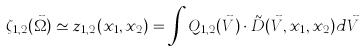<formula> <loc_0><loc_0><loc_500><loc_500>\zeta _ { 1 , 2 } ( \vec { \Omega } ) \simeq z _ { 1 , 2 } ( x _ { 1 } , x _ { 2 } ) = \int Q _ { 1 , 2 } ( \vec { V } ) \cdot \tilde { D } ( \vec { V } , x _ { 1 } , x _ { 2 } ) d \vec { V }</formula> 